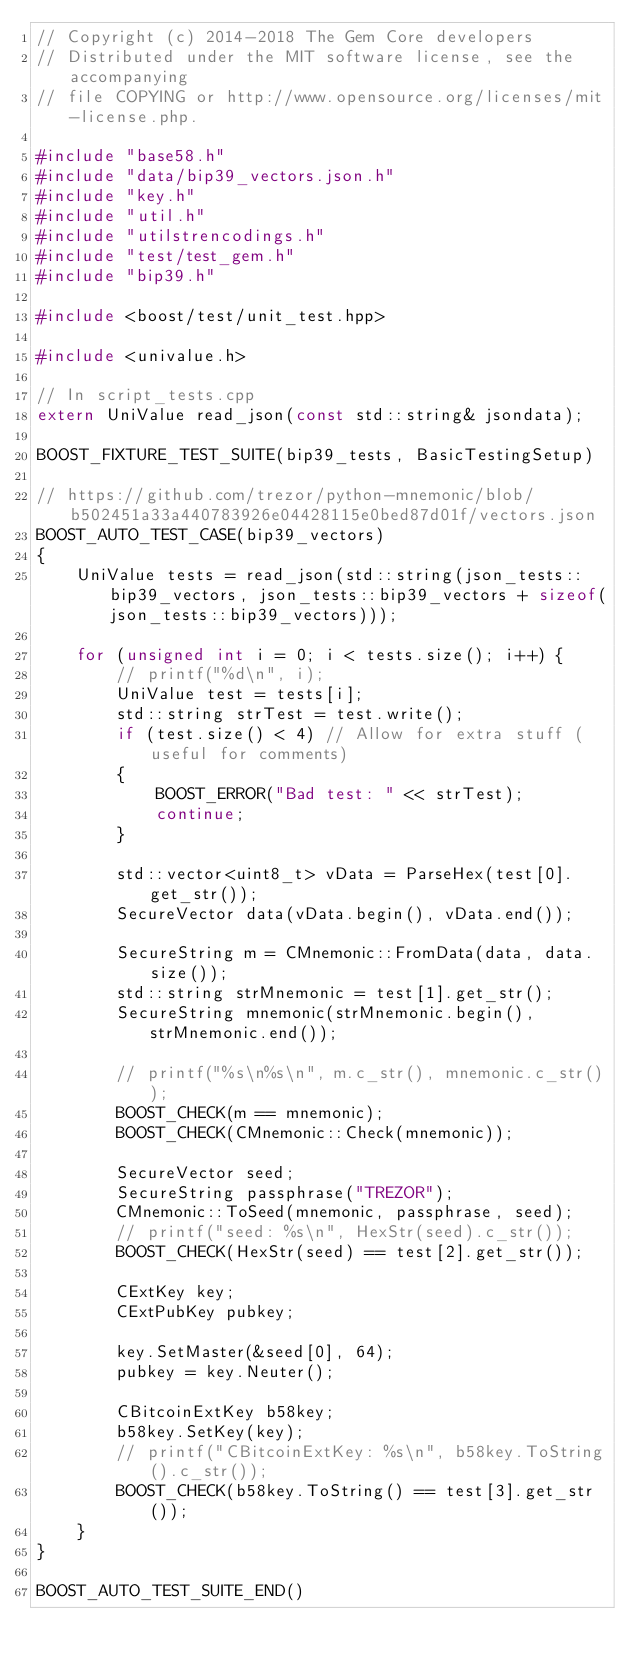<code> <loc_0><loc_0><loc_500><loc_500><_C++_>// Copyright (c) 2014-2018 The Gem Core developers
// Distributed under the MIT software license, see the accompanying
// file COPYING or http://www.opensource.org/licenses/mit-license.php.

#include "base58.h"
#include "data/bip39_vectors.json.h"
#include "key.h"
#include "util.h"
#include "utilstrencodings.h"
#include "test/test_gem.h"
#include "bip39.h"

#include <boost/test/unit_test.hpp>

#include <univalue.h>

// In script_tests.cpp
extern UniValue read_json(const std::string& jsondata);

BOOST_FIXTURE_TEST_SUITE(bip39_tests, BasicTestingSetup)

// https://github.com/trezor/python-mnemonic/blob/b502451a33a440783926e04428115e0bed87d01f/vectors.json
BOOST_AUTO_TEST_CASE(bip39_vectors)
{
    UniValue tests = read_json(std::string(json_tests::bip39_vectors, json_tests::bip39_vectors + sizeof(json_tests::bip39_vectors)));

    for (unsigned int i = 0; i < tests.size(); i++) {
        // printf("%d\n", i);
        UniValue test = tests[i];
        std::string strTest = test.write();
        if (test.size() < 4) // Allow for extra stuff (useful for comments)
        {
            BOOST_ERROR("Bad test: " << strTest);
            continue;
        }

        std::vector<uint8_t> vData = ParseHex(test[0].get_str());
        SecureVector data(vData.begin(), vData.end());

        SecureString m = CMnemonic::FromData(data, data.size());
        std::string strMnemonic = test[1].get_str();
        SecureString mnemonic(strMnemonic.begin(), strMnemonic.end());

        // printf("%s\n%s\n", m.c_str(), mnemonic.c_str());
        BOOST_CHECK(m == mnemonic);
        BOOST_CHECK(CMnemonic::Check(mnemonic));

        SecureVector seed;
        SecureString passphrase("TREZOR");
        CMnemonic::ToSeed(mnemonic, passphrase, seed);
        // printf("seed: %s\n", HexStr(seed).c_str());
        BOOST_CHECK(HexStr(seed) == test[2].get_str());

        CExtKey key;
        CExtPubKey pubkey;

        key.SetMaster(&seed[0], 64);
        pubkey = key.Neuter();

        CBitcoinExtKey b58key;
        b58key.SetKey(key);
        // printf("CBitcoinExtKey: %s\n", b58key.ToString().c_str());
        BOOST_CHECK(b58key.ToString() == test[3].get_str());
    }
}

BOOST_AUTO_TEST_SUITE_END()
</code> 